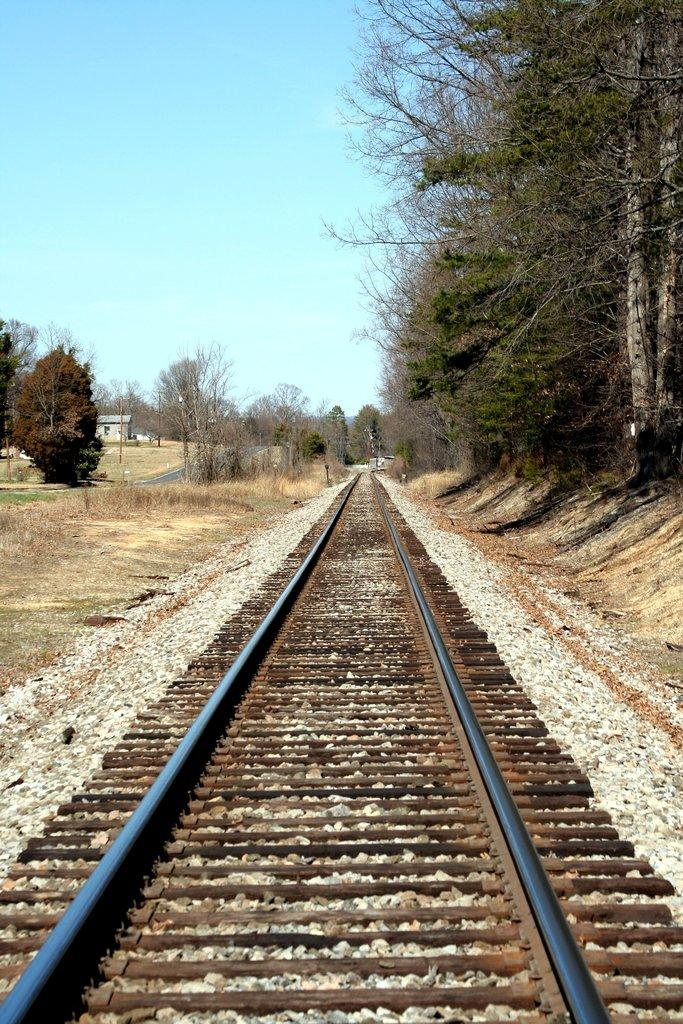What is the main feature in the center of the image? There is a track in the center of the image. What type of natural elements can be seen in the image? Stones, plants, grass, and a group of trees are present in the image. What type of structure is visible in the image? There is a house with a roof in the image. What is the condition of the sky in the image? The sky is visible in the image and appears cloudy. What type of mint is being used to season the vessel in the image? There is no mint or vessel present in the image. Can you tell me how many firemen are visible in the image? There are no firemen present in the image. 